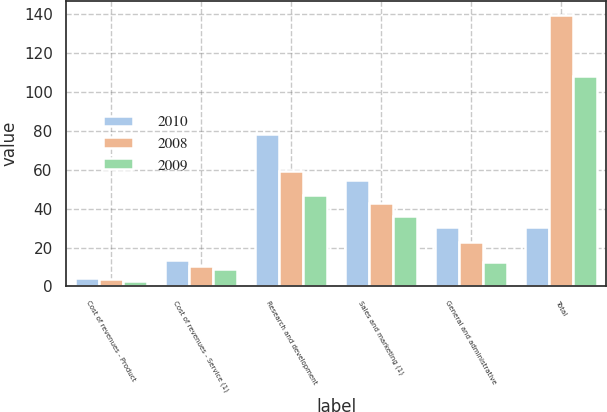<chart> <loc_0><loc_0><loc_500><loc_500><stacked_bar_chart><ecel><fcel>Cost of revenues - Product<fcel>Cost of revenues - Service (1)<fcel>Research and development<fcel>Sales and marketing (1)<fcel>General and administrative<fcel>Total<nl><fcel>2010<fcel>4.4<fcel>13.5<fcel>78.5<fcel>54.9<fcel>30.7<fcel>30.7<nl><fcel>2008<fcel>3.9<fcel>10.5<fcel>59.3<fcel>43.1<fcel>22.9<fcel>139.7<nl><fcel>2009<fcel>3<fcel>9.2<fcel>47<fcel>36.2<fcel>12.7<fcel>108.1<nl></chart> 